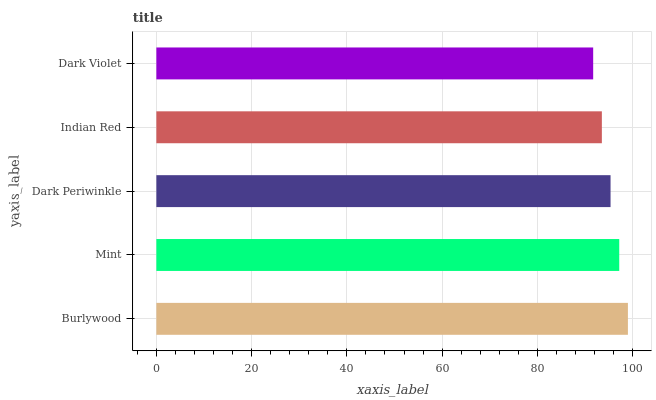Is Dark Violet the minimum?
Answer yes or no. Yes. Is Burlywood the maximum?
Answer yes or no. Yes. Is Mint the minimum?
Answer yes or no. No. Is Mint the maximum?
Answer yes or no. No. Is Burlywood greater than Mint?
Answer yes or no. Yes. Is Mint less than Burlywood?
Answer yes or no. Yes. Is Mint greater than Burlywood?
Answer yes or no. No. Is Burlywood less than Mint?
Answer yes or no. No. Is Dark Periwinkle the high median?
Answer yes or no. Yes. Is Dark Periwinkle the low median?
Answer yes or no. Yes. Is Mint the high median?
Answer yes or no. No. Is Dark Violet the low median?
Answer yes or no. No. 